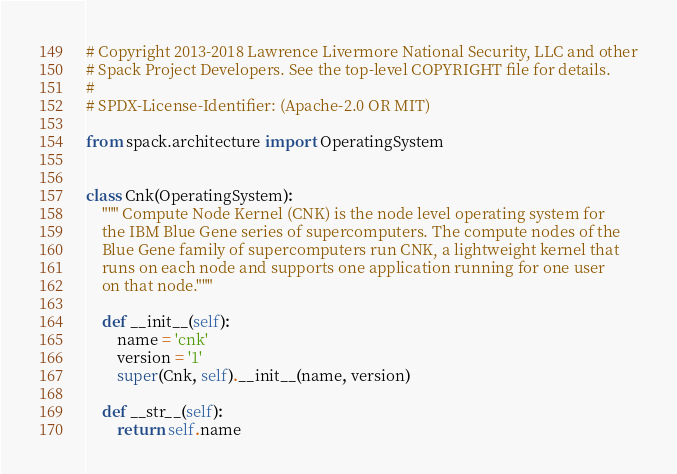<code> <loc_0><loc_0><loc_500><loc_500><_Python_># Copyright 2013-2018 Lawrence Livermore National Security, LLC and other
# Spack Project Developers. See the top-level COPYRIGHT file for details.
#
# SPDX-License-Identifier: (Apache-2.0 OR MIT)

from spack.architecture import OperatingSystem


class Cnk(OperatingSystem):
    """ Compute Node Kernel (CNK) is the node level operating system for
    the IBM Blue Gene series of supercomputers. The compute nodes of the
    Blue Gene family of supercomputers run CNK, a lightweight kernel that
    runs on each node and supports one application running for one user
    on that node."""

    def __init__(self):
        name = 'cnk'
        version = '1'
        super(Cnk, self).__init__(name, version)

    def __str__(self):
        return self.name
</code> 